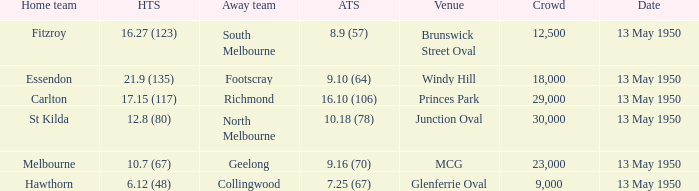What was the lowest crowd size at the Windy Hill venue? 18000.0. 